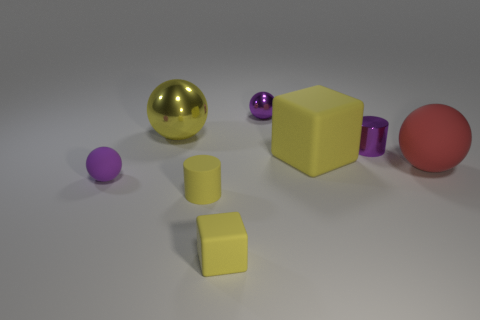Subtract all blue spheres. Subtract all red cubes. How many spheres are left? 4 Subtract all cylinders. How many objects are left? 6 Subtract 1 yellow cylinders. How many objects are left? 7 Subtract all purple matte objects. Subtract all yellow matte blocks. How many objects are left? 5 Add 8 big yellow matte things. How many big yellow matte things are left? 9 Add 2 purple metal objects. How many purple metal objects exist? 4 